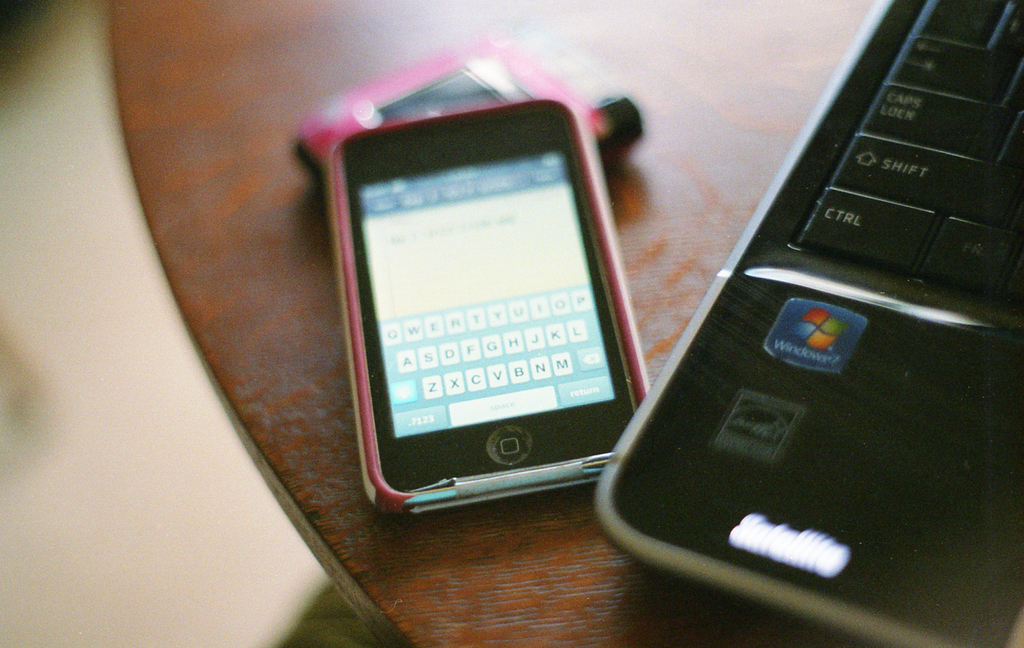Provide a one-sentence caption for the provided image. An old-fashioned phone with a physical keyboard rests beside a laptop displaying the iconic Windows logo, evoking a sense of early 2000s technology nostalgia. 